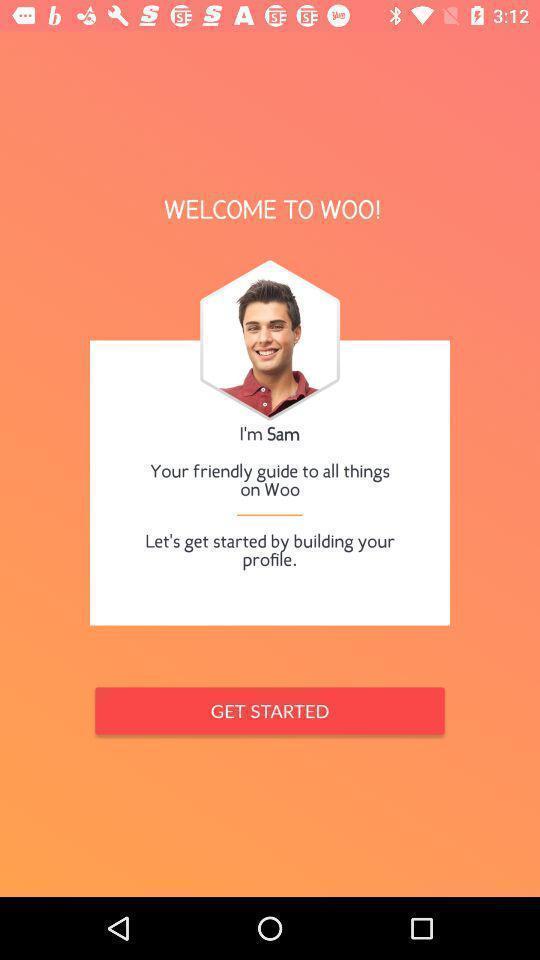Explain what's happening in this screen capture. Welcome page of the app. 